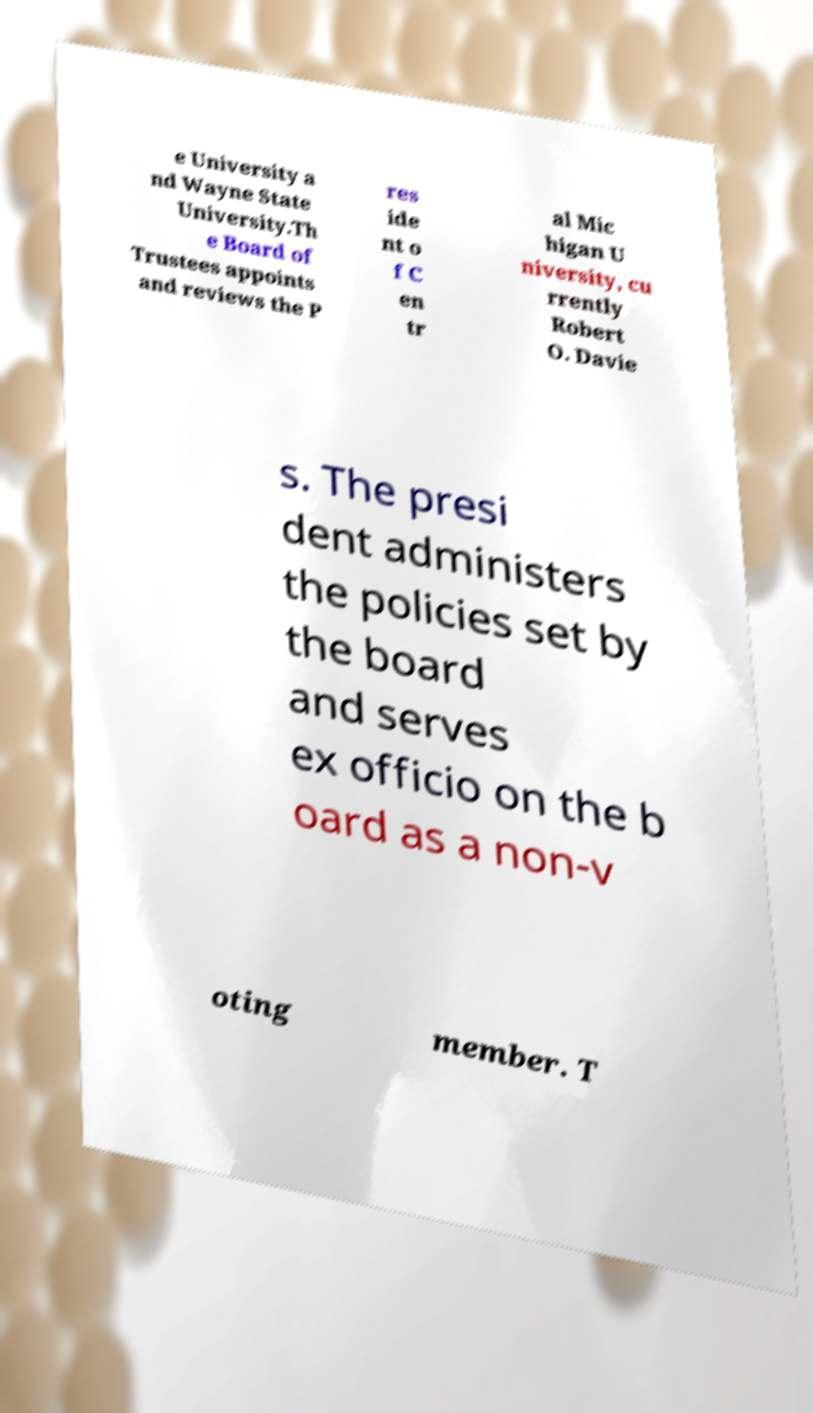I need the written content from this picture converted into text. Can you do that? e University a nd Wayne State University.Th e Board of Trustees appoints and reviews the P res ide nt o f C en tr al Mic higan U niversity, cu rrently Robert O. Davie s. The presi dent administers the policies set by the board and serves ex officio on the b oard as a non-v oting member. T 